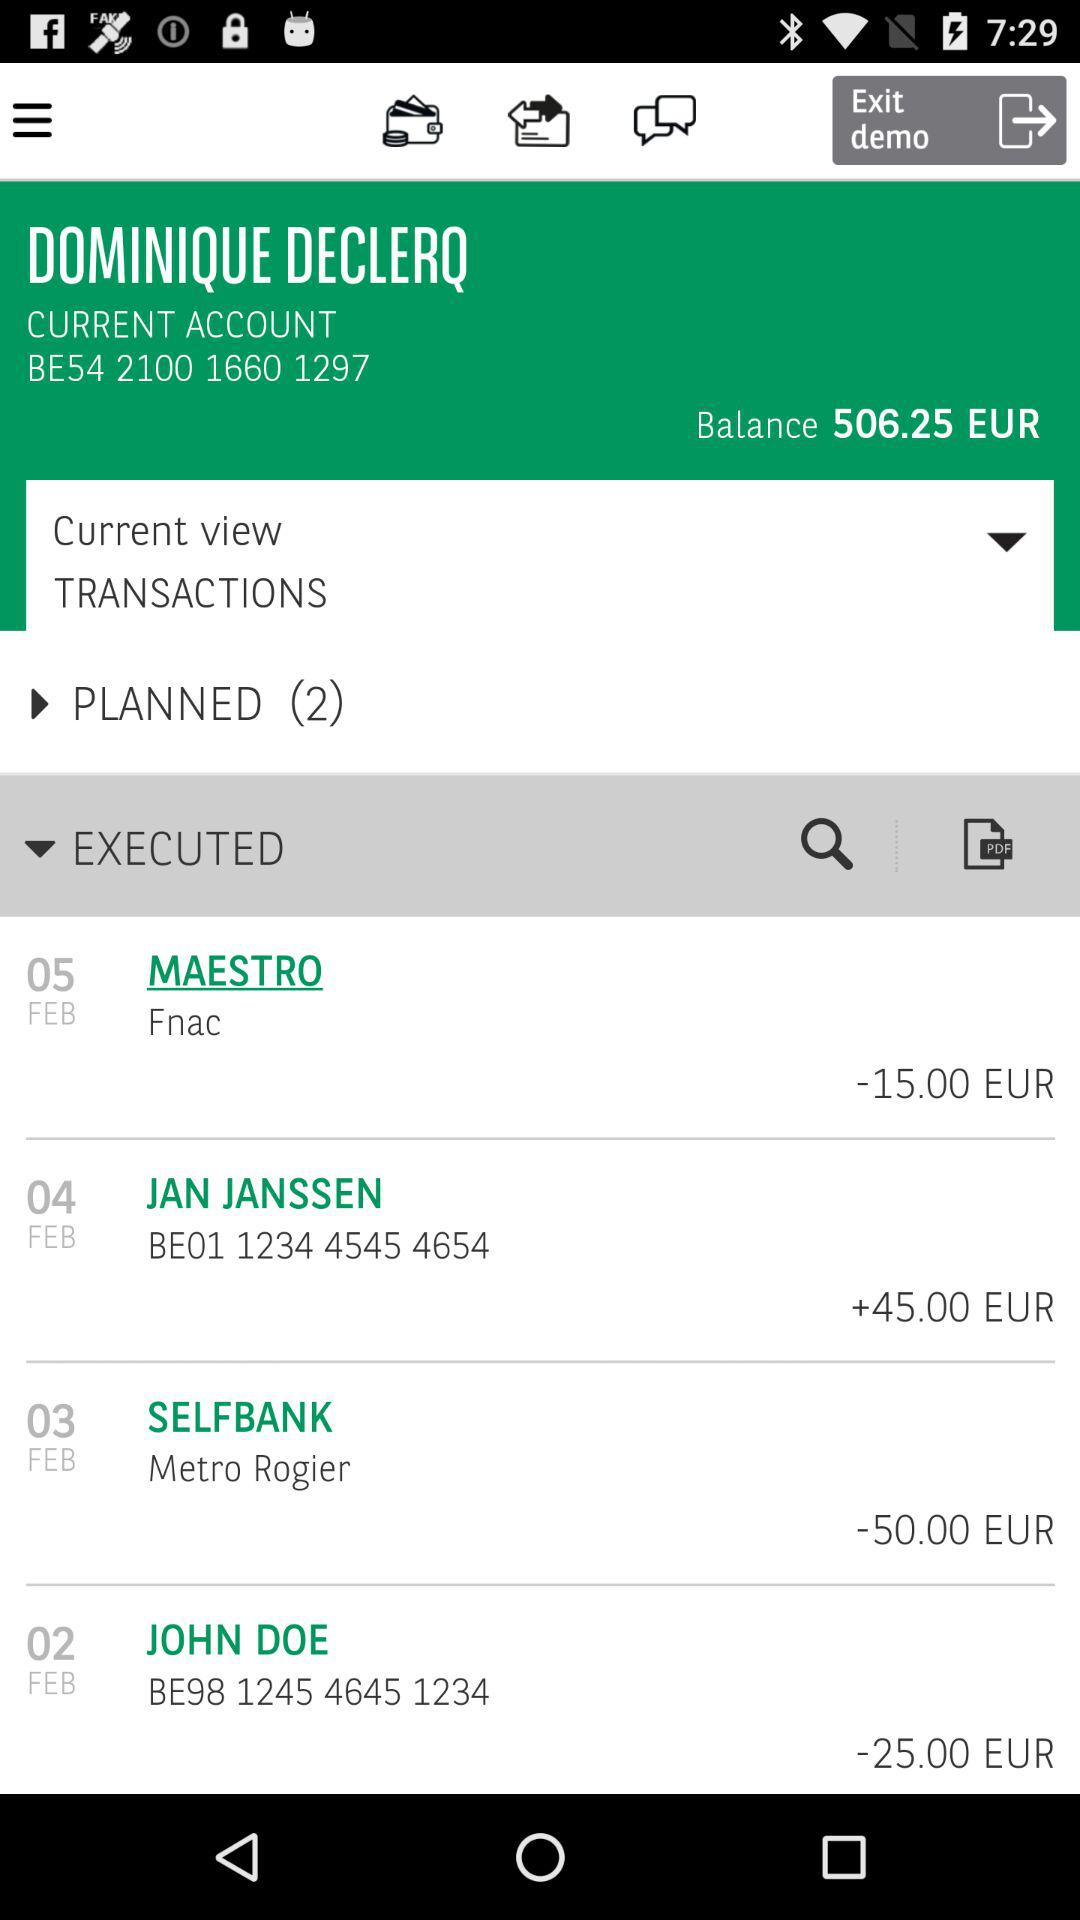How many more transactions are there in the EXECUTED section than in the PLANNED section?
Answer the question using a single word or phrase. 2 